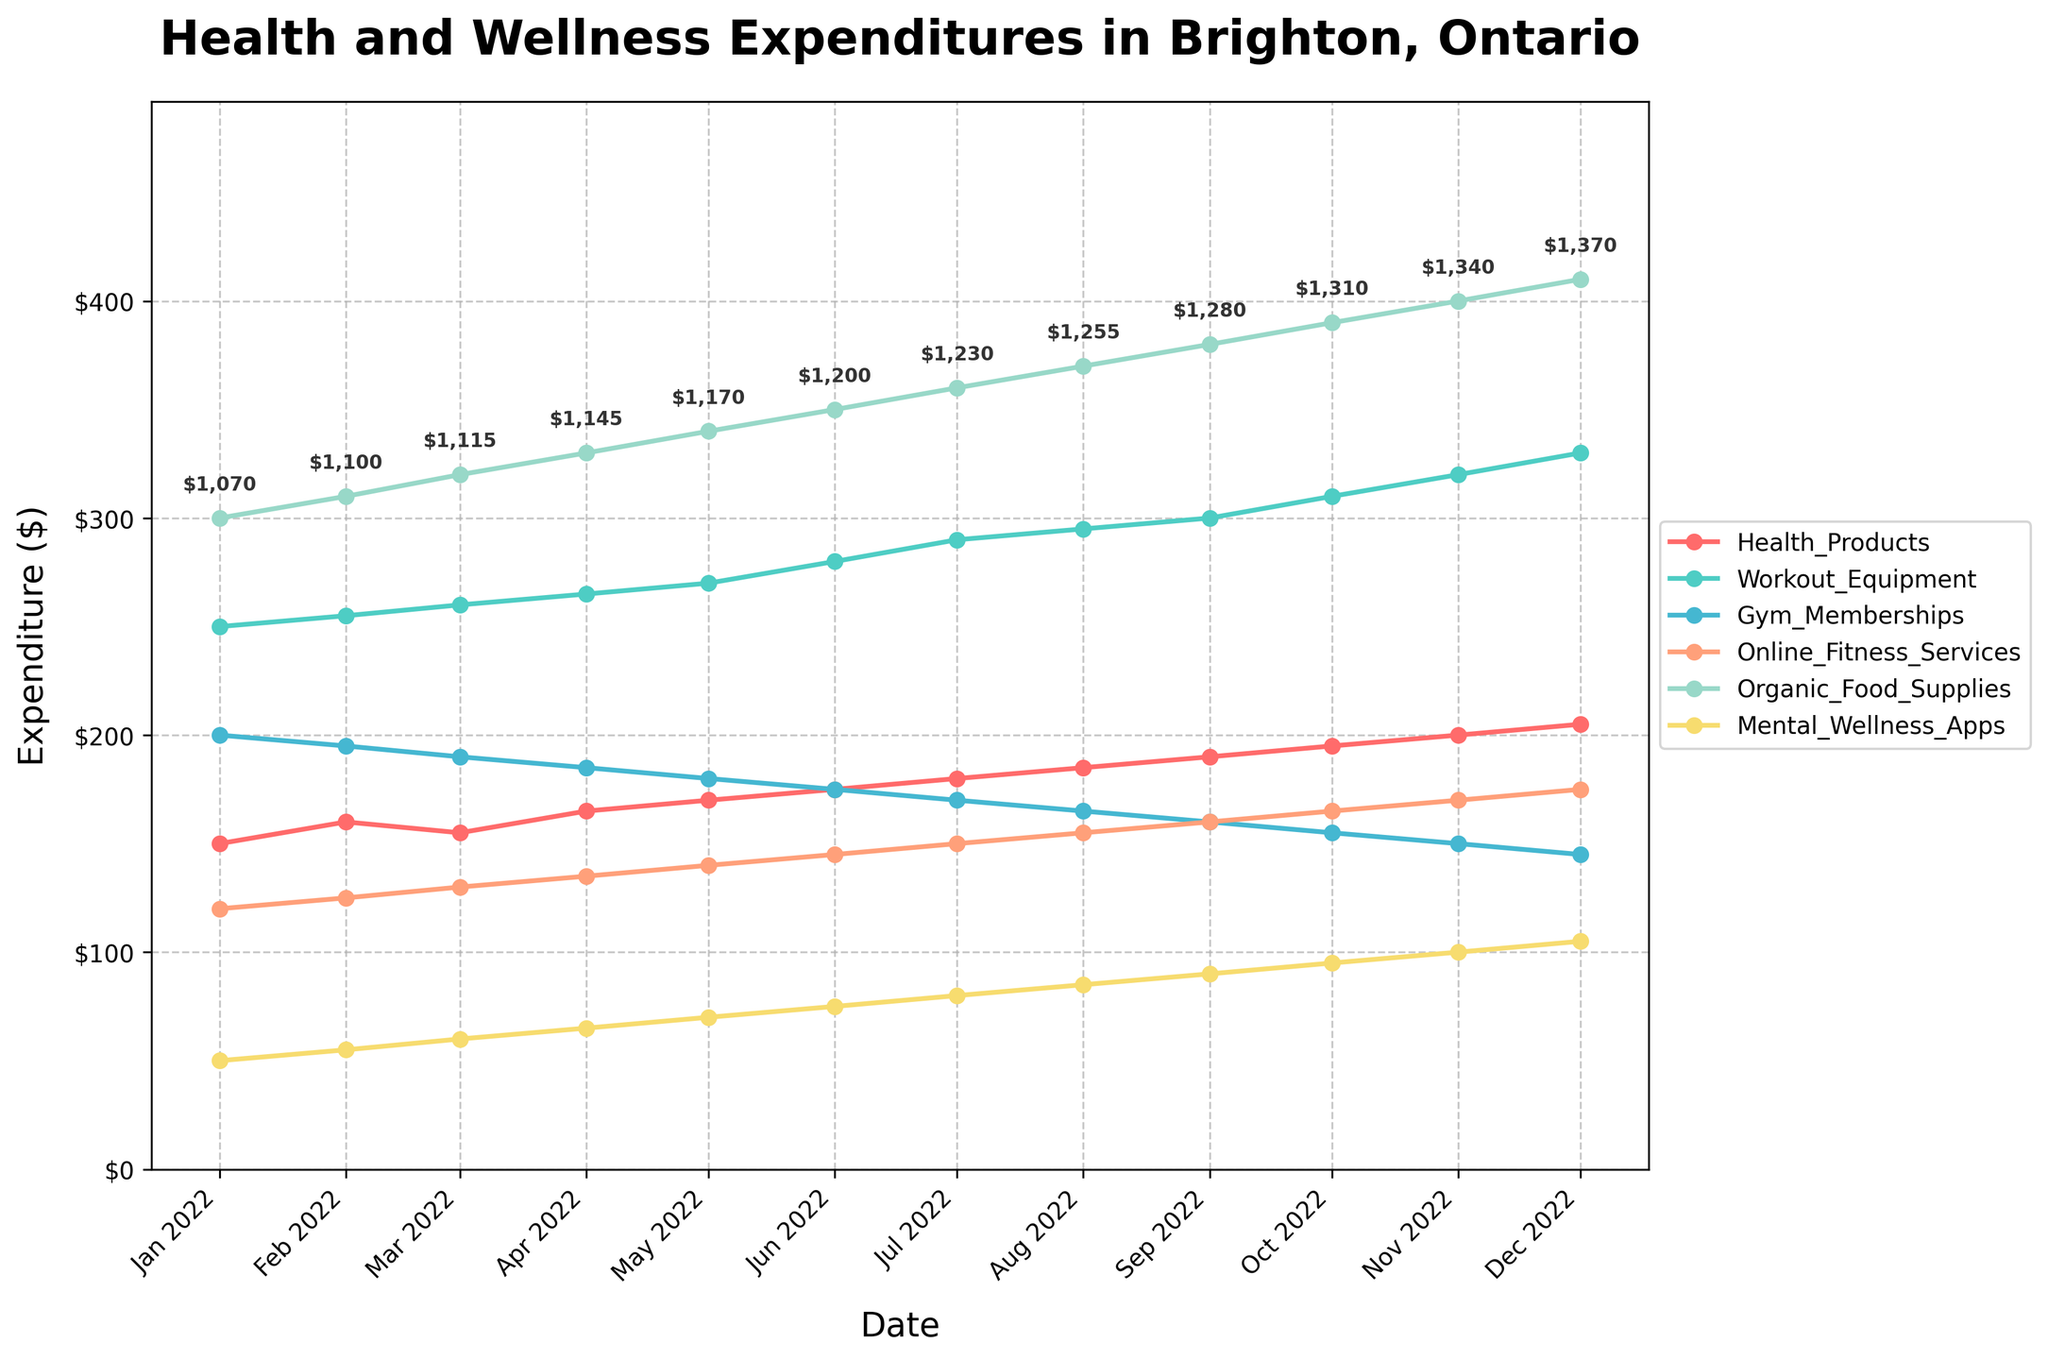what is the title of the plot? The title is usually placed at the top of the figure. In this case, it is clearly stated as "Health and Wellness Expenditures in Brighton, Ontario".
Answer: Health and Wellness Expenditures in Brighton, Ontario which category has the maximum expenditure in December 2022? Look at the data points for December 2022 and identify the highest expenditure among the categories. Organic Food Supplies has the highest value of $410.
Answer: Organic Food Supplies how has the expenditure on Mental_Wellness_Apps changed from January 2022 to December 2022? Observe the trend for Mental_Wellness_Apps from January to December. It has gradually increased from $50 in January to $105 in December.
Answer: increased from $50 to $105 which month had the lowest expenditure on Gym_Memberships? Check each month's expenses on Gym Memberships and find the lowest value. The month with the lowest expenditure is December 2022 with $145.
Answer: December 2022 how do the expenditures on Online_Fitness_Services change over time from January to December 2022? Trace the line representing Online Fitness Services from January ($120) to December ($175). It shows a steady increase over the months.
Answer: steadily increased what is the total family expenditure in September 2022? Refer to the annotated text at September 2022, which shows a total expenditure of $1280.
Answer: $1280 which two categories have the closest expenditures in July 2022? Compare the values for different categories in July 2022. Gym Memberships and Organic Food Supplies have close values of $170 and $360, respectively.
Answer: Gym Memberships and Organic Food Supplies what is the average expenditure on Health_Products from January to December 2022? Add the monthly expenditures on Health Products ($150+$160+$155+$165+$170+$175+$180+$185+$190+$195+$200+$205) and divide by 12. The sum is $2,230, so the average is $2,230/12 ≈ $185.83.
Answer: $185.83 which category had the steepest increase in expenditure over the year? Compare the differences between January and December for each category. Organic Food Supplies had the largest increase, from $300 to $410, an increase of $110.
Answer: Organic Food Supplies 